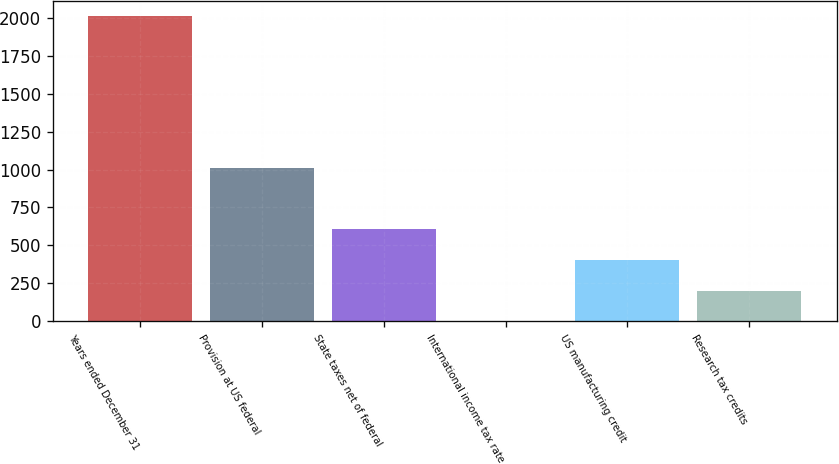Convert chart. <chart><loc_0><loc_0><loc_500><loc_500><bar_chart><fcel>Years ended December 31<fcel>Provision at US federal<fcel>State taxes net of federal<fcel>International income tax rate<fcel>US manufacturing credit<fcel>Research tax credits<nl><fcel>2015<fcel>1007.6<fcel>604.64<fcel>0.2<fcel>403.16<fcel>201.68<nl></chart> 